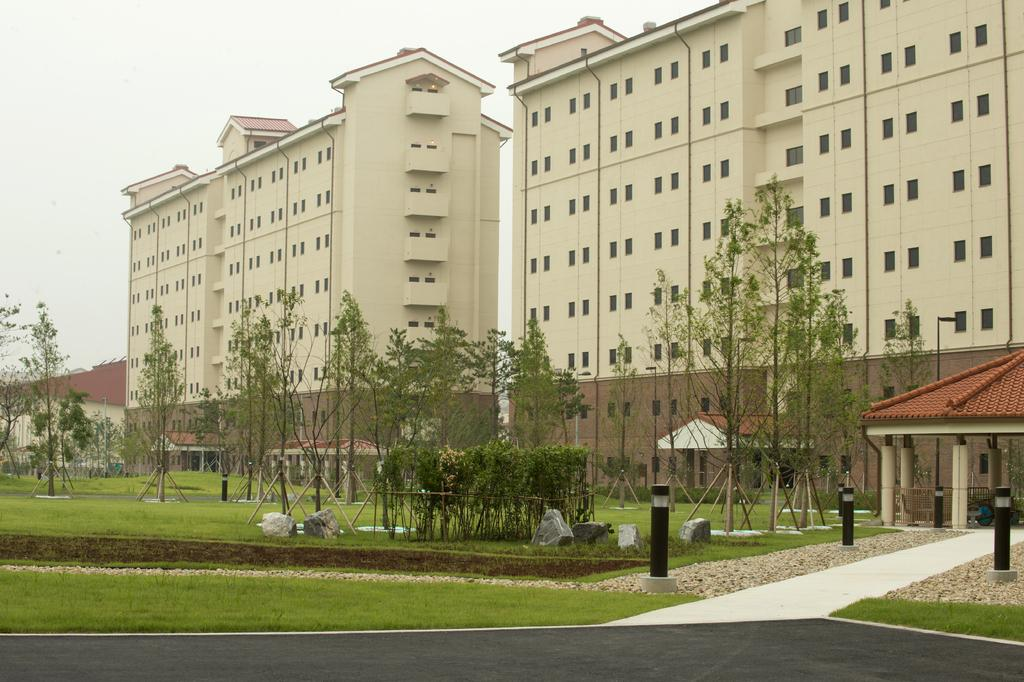What type of structures can be seen in the image? There are buildings in the image. What is located in front of the buildings? There are trees and an open-shed in front of the buildings. What type of lighting is present in the image? Lights are present in the image. What architectural features can be seen in the image? Pillars are visible in the image. What type of vegetation is present in the image? Grass is present in the image. What type of natural elements can be seen in the image? Rocks are visible in the image. What is visible in the background of the image? The sky is visible in the background of the image. How many cobwebs can be seen hanging from the pillars in the image? There are no cobwebs visible in the image. What is the chance of rain in the image? The image does not provide any information about the weather or the chance of rain. 